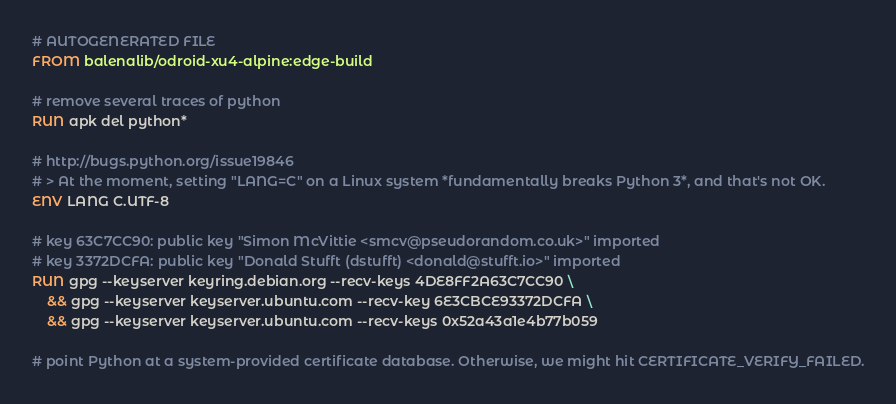Convert code to text. <code><loc_0><loc_0><loc_500><loc_500><_Dockerfile_># AUTOGENERATED FILE
FROM balenalib/odroid-xu4-alpine:edge-build

# remove several traces of python
RUN apk del python*

# http://bugs.python.org/issue19846
# > At the moment, setting "LANG=C" on a Linux system *fundamentally breaks Python 3*, and that's not OK.
ENV LANG C.UTF-8

# key 63C7CC90: public key "Simon McVittie <smcv@pseudorandom.co.uk>" imported
# key 3372DCFA: public key "Donald Stufft (dstufft) <donald@stufft.io>" imported
RUN gpg --keyserver keyring.debian.org --recv-keys 4DE8FF2A63C7CC90 \
	&& gpg --keyserver keyserver.ubuntu.com --recv-key 6E3CBCE93372DCFA \
	&& gpg --keyserver keyserver.ubuntu.com --recv-keys 0x52a43a1e4b77b059

# point Python at a system-provided certificate database. Otherwise, we might hit CERTIFICATE_VERIFY_FAILED.</code> 